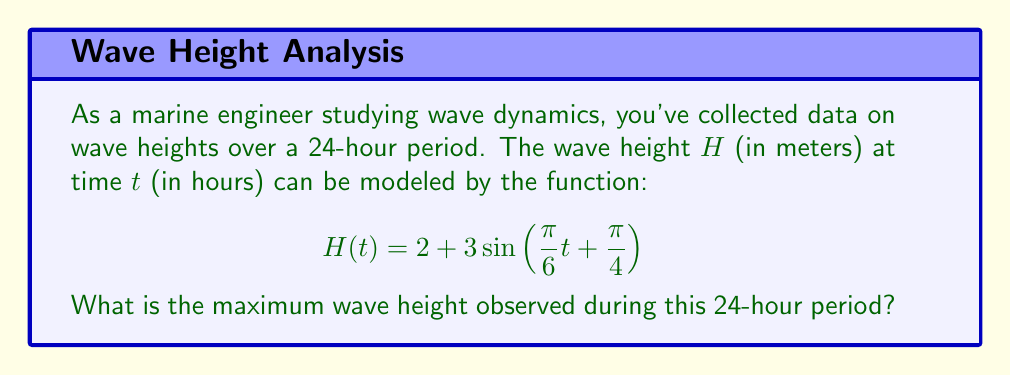Give your solution to this math problem. To find the maximum wave height, we need to follow these steps:

1) The sine function oscillates between -1 and 1. The maximum value of sine is 1.

2) In our function $H(t) = 2 + 3\sin(\frac{\pi}{6}t + \frac{\pi}{4})$, we have:
   - A vertical shift of 2 meters (the constant term)
   - An amplitude of 3 meters (the coefficient of sine)

3) The maximum value will occur when $\sin(\frac{\pi}{6}t + \frac{\pi}{4}) = 1$

4) At this point, the height will be:
   $$H_{max} = 2 + 3(1) = 2 + 3 = 5$$

5) We don't need to solve for the specific time when this occurs, as the question only asks for the maximum height.

Therefore, the maximum wave height observed during the 24-hour period is 5 meters.
Answer: 5 meters 